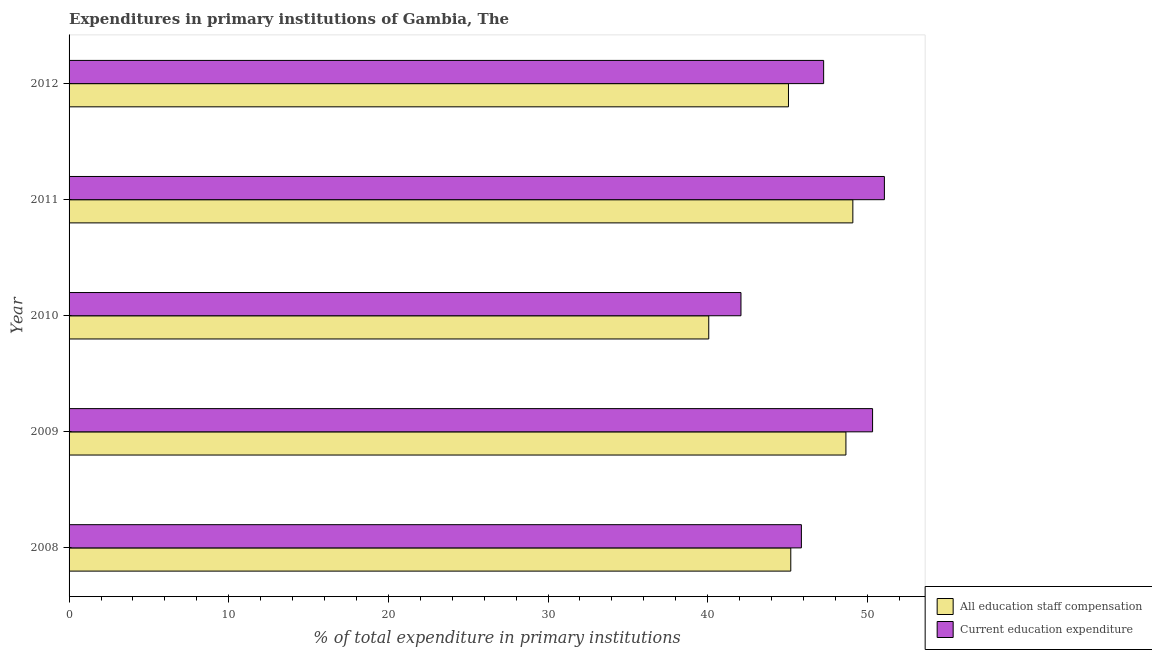How many different coloured bars are there?
Make the answer very short. 2. How many groups of bars are there?
Your answer should be compact. 5. How many bars are there on the 3rd tick from the top?
Make the answer very short. 2. What is the expenditure in staff compensation in 2012?
Offer a very short reply. 45.06. Across all years, what is the maximum expenditure in staff compensation?
Your answer should be compact. 49.09. Across all years, what is the minimum expenditure in staff compensation?
Ensure brevity in your answer.  40.06. In which year was the expenditure in staff compensation maximum?
Your answer should be compact. 2011. In which year was the expenditure in education minimum?
Your answer should be compact. 2010. What is the total expenditure in education in the graph?
Provide a succinct answer. 236.6. What is the difference between the expenditure in staff compensation in 2009 and that in 2010?
Give a very brief answer. 8.59. What is the difference between the expenditure in education in 2011 and the expenditure in staff compensation in 2012?
Offer a very short reply. 6.01. What is the average expenditure in education per year?
Your answer should be very brief. 47.32. In the year 2012, what is the difference between the expenditure in education and expenditure in staff compensation?
Keep it short and to the point. 2.2. Is the expenditure in staff compensation in 2011 less than that in 2012?
Your response must be concise. No. What is the difference between the highest and the second highest expenditure in staff compensation?
Your answer should be very brief. 0.43. What is the difference between the highest and the lowest expenditure in education?
Ensure brevity in your answer.  8.98. What does the 2nd bar from the top in 2009 represents?
Your response must be concise. All education staff compensation. What does the 2nd bar from the bottom in 2010 represents?
Provide a short and direct response. Current education expenditure. Are all the bars in the graph horizontal?
Keep it short and to the point. Yes. How many years are there in the graph?
Your answer should be compact. 5. Are the values on the major ticks of X-axis written in scientific E-notation?
Your answer should be very brief. No. Does the graph contain any zero values?
Ensure brevity in your answer.  No. Where does the legend appear in the graph?
Ensure brevity in your answer.  Bottom right. How are the legend labels stacked?
Your answer should be compact. Vertical. What is the title of the graph?
Your response must be concise. Expenditures in primary institutions of Gambia, The. Does "Working capital" appear as one of the legend labels in the graph?
Give a very brief answer. No. What is the label or title of the X-axis?
Your answer should be very brief. % of total expenditure in primary institutions. What is the % of total expenditure in primary institutions in All education staff compensation in 2008?
Your response must be concise. 45.2. What is the % of total expenditure in primary institutions of Current education expenditure in 2008?
Offer a terse response. 45.87. What is the % of total expenditure in primary institutions of All education staff compensation in 2009?
Your answer should be compact. 48.66. What is the % of total expenditure in primary institutions in Current education expenditure in 2009?
Your response must be concise. 50.33. What is the % of total expenditure in primary institutions of All education staff compensation in 2010?
Your answer should be compact. 40.06. What is the % of total expenditure in primary institutions of Current education expenditure in 2010?
Give a very brief answer. 42.08. What is the % of total expenditure in primary institutions in All education staff compensation in 2011?
Provide a short and direct response. 49.09. What is the % of total expenditure in primary institutions of Current education expenditure in 2011?
Ensure brevity in your answer.  51.07. What is the % of total expenditure in primary institutions of All education staff compensation in 2012?
Provide a succinct answer. 45.06. What is the % of total expenditure in primary institutions in Current education expenditure in 2012?
Give a very brief answer. 47.26. Across all years, what is the maximum % of total expenditure in primary institutions in All education staff compensation?
Offer a terse response. 49.09. Across all years, what is the maximum % of total expenditure in primary institutions of Current education expenditure?
Offer a very short reply. 51.07. Across all years, what is the minimum % of total expenditure in primary institutions in All education staff compensation?
Keep it short and to the point. 40.06. Across all years, what is the minimum % of total expenditure in primary institutions in Current education expenditure?
Your answer should be compact. 42.08. What is the total % of total expenditure in primary institutions in All education staff compensation in the graph?
Ensure brevity in your answer.  228.07. What is the total % of total expenditure in primary institutions in Current education expenditure in the graph?
Provide a short and direct response. 236.6. What is the difference between the % of total expenditure in primary institutions in All education staff compensation in 2008 and that in 2009?
Keep it short and to the point. -3.45. What is the difference between the % of total expenditure in primary institutions of Current education expenditure in 2008 and that in 2009?
Provide a succinct answer. -4.46. What is the difference between the % of total expenditure in primary institutions in All education staff compensation in 2008 and that in 2010?
Your answer should be very brief. 5.14. What is the difference between the % of total expenditure in primary institutions of Current education expenditure in 2008 and that in 2010?
Make the answer very short. 3.78. What is the difference between the % of total expenditure in primary institutions of All education staff compensation in 2008 and that in 2011?
Offer a terse response. -3.89. What is the difference between the % of total expenditure in primary institutions of Current education expenditure in 2008 and that in 2011?
Ensure brevity in your answer.  -5.2. What is the difference between the % of total expenditure in primary institutions in All education staff compensation in 2008 and that in 2012?
Keep it short and to the point. 0.15. What is the difference between the % of total expenditure in primary institutions of Current education expenditure in 2008 and that in 2012?
Your answer should be very brief. -1.39. What is the difference between the % of total expenditure in primary institutions in All education staff compensation in 2009 and that in 2010?
Provide a succinct answer. 8.59. What is the difference between the % of total expenditure in primary institutions in Current education expenditure in 2009 and that in 2010?
Your answer should be very brief. 8.24. What is the difference between the % of total expenditure in primary institutions of All education staff compensation in 2009 and that in 2011?
Keep it short and to the point. -0.43. What is the difference between the % of total expenditure in primary institutions of Current education expenditure in 2009 and that in 2011?
Give a very brief answer. -0.74. What is the difference between the % of total expenditure in primary institutions in All education staff compensation in 2009 and that in 2012?
Ensure brevity in your answer.  3.6. What is the difference between the % of total expenditure in primary institutions in Current education expenditure in 2009 and that in 2012?
Your response must be concise. 3.07. What is the difference between the % of total expenditure in primary institutions in All education staff compensation in 2010 and that in 2011?
Keep it short and to the point. -9.03. What is the difference between the % of total expenditure in primary institutions in Current education expenditure in 2010 and that in 2011?
Give a very brief answer. -8.98. What is the difference between the % of total expenditure in primary institutions of All education staff compensation in 2010 and that in 2012?
Your response must be concise. -4.99. What is the difference between the % of total expenditure in primary institutions in Current education expenditure in 2010 and that in 2012?
Your answer should be very brief. -5.18. What is the difference between the % of total expenditure in primary institutions of All education staff compensation in 2011 and that in 2012?
Give a very brief answer. 4.03. What is the difference between the % of total expenditure in primary institutions of Current education expenditure in 2011 and that in 2012?
Offer a terse response. 3.8. What is the difference between the % of total expenditure in primary institutions in All education staff compensation in 2008 and the % of total expenditure in primary institutions in Current education expenditure in 2009?
Provide a succinct answer. -5.12. What is the difference between the % of total expenditure in primary institutions in All education staff compensation in 2008 and the % of total expenditure in primary institutions in Current education expenditure in 2010?
Your answer should be very brief. 3.12. What is the difference between the % of total expenditure in primary institutions in All education staff compensation in 2008 and the % of total expenditure in primary institutions in Current education expenditure in 2011?
Your answer should be compact. -5.86. What is the difference between the % of total expenditure in primary institutions of All education staff compensation in 2008 and the % of total expenditure in primary institutions of Current education expenditure in 2012?
Make the answer very short. -2.06. What is the difference between the % of total expenditure in primary institutions of All education staff compensation in 2009 and the % of total expenditure in primary institutions of Current education expenditure in 2010?
Your answer should be compact. 6.57. What is the difference between the % of total expenditure in primary institutions in All education staff compensation in 2009 and the % of total expenditure in primary institutions in Current education expenditure in 2011?
Offer a very short reply. -2.41. What is the difference between the % of total expenditure in primary institutions in All education staff compensation in 2009 and the % of total expenditure in primary institutions in Current education expenditure in 2012?
Provide a short and direct response. 1.4. What is the difference between the % of total expenditure in primary institutions of All education staff compensation in 2010 and the % of total expenditure in primary institutions of Current education expenditure in 2011?
Offer a very short reply. -11. What is the difference between the % of total expenditure in primary institutions of All education staff compensation in 2010 and the % of total expenditure in primary institutions of Current education expenditure in 2012?
Give a very brief answer. -7.2. What is the difference between the % of total expenditure in primary institutions of All education staff compensation in 2011 and the % of total expenditure in primary institutions of Current education expenditure in 2012?
Offer a very short reply. 1.83. What is the average % of total expenditure in primary institutions of All education staff compensation per year?
Your answer should be very brief. 45.61. What is the average % of total expenditure in primary institutions of Current education expenditure per year?
Offer a very short reply. 47.32. In the year 2008, what is the difference between the % of total expenditure in primary institutions of All education staff compensation and % of total expenditure in primary institutions of Current education expenditure?
Your answer should be very brief. -0.66. In the year 2009, what is the difference between the % of total expenditure in primary institutions in All education staff compensation and % of total expenditure in primary institutions in Current education expenditure?
Provide a succinct answer. -1.67. In the year 2010, what is the difference between the % of total expenditure in primary institutions of All education staff compensation and % of total expenditure in primary institutions of Current education expenditure?
Make the answer very short. -2.02. In the year 2011, what is the difference between the % of total expenditure in primary institutions of All education staff compensation and % of total expenditure in primary institutions of Current education expenditure?
Offer a very short reply. -1.98. In the year 2012, what is the difference between the % of total expenditure in primary institutions of All education staff compensation and % of total expenditure in primary institutions of Current education expenditure?
Offer a terse response. -2.2. What is the ratio of the % of total expenditure in primary institutions of All education staff compensation in 2008 to that in 2009?
Ensure brevity in your answer.  0.93. What is the ratio of the % of total expenditure in primary institutions in Current education expenditure in 2008 to that in 2009?
Offer a terse response. 0.91. What is the ratio of the % of total expenditure in primary institutions of All education staff compensation in 2008 to that in 2010?
Provide a succinct answer. 1.13. What is the ratio of the % of total expenditure in primary institutions of Current education expenditure in 2008 to that in 2010?
Make the answer very short. 1.09. What is the ratio of the % of total expenditure in primary institutions in All education staff compensation in 2008 to that in 2011?
Make the answer very short. 0.92. What is the ratio of the % of total expenditure in primary institutions in Current education expenditure in 2008 to that in 2011?
Give a very brief answer. 0.9. What is the ratio of the % of total expenditure in primary institutions of All education staff compensation in 2008 to that in 2012?
Make the answer very short. 1. What is the ratio of the % of total expenditure in primary institutions in Current education expenditure in 2008 to that in 2012?
Provide a succinct answer. 0.97. What is the ratio of the % of total expenditure in primary institutions of All education staff compensation in 2009 to that in 2010?
Your answer should be very brief. 1.21. What is the ratio of the % of total expenditure in primary institutions in Current education expenditure in 2009 to that in 2010?
Offer a very short reply. 1.2. What is the ratio of the % of total expenditure in primary institutions in Current education expenditure in 2009 to that in 2011?
Make the answer very short. 0.99. What is the ratio of the % of total expenditure in primary institutions of All education staff compensation in 2009 to that in 2012?
Give a very brief answer. 1.08. What is the ratio of the % of total expenditure in primary institutions of Current education expenditure in 2009 to that in 2012?
Offer a terse response. 1.06. What is the ratio of the % of total expenditure in primary institutions of All education staff compensation in 2010 to that in 2011?
Provide a short and direct response. 0.82. What is the ratio of the % of total expenditure in primary institutions of Current education expenditure in 2010 to that in 2011?
Offer a terse response. 0.82. What is the ratio of the % of total expenditure in primary institutions of All education staff compensation in 2010 to that in 2012?
Provide a short and direct response. 0.89. What is the ratio of the % of total expenditure in primary institutions in Current education expenditure in 2010 to that in 2012?
Make the answer very short. 0.89. What is the ratio of the % of total expenditure in primary institutions of All education staff compensation in 2011 to that in 2012?
Your response must be concise. 1.09. What is the ratio of the % of total expenditure in primary institutions of Current education expenditure in 2011 to that in 2012?
Ensure brevity in your answer.  1.08. What is the difference between the highest and the second highest % of total expenditure in primary institutions of All education staff compensation?
Offer a very short reply. 0.43. What is the difference between the highest and the second highest % of total expenditure in primary institutions of Current education expenditure?
Give a very brief answer. 0.74. What is the difference between the highest and the lowest % of total expenditure in primary institutions in All education staff compensation?
Give a very brief answer. 9.03. What is the difference between the highest and the lowest % of total expenditure in primary institutions in Current education expenditure?
Make the answer very short. 8.98. 